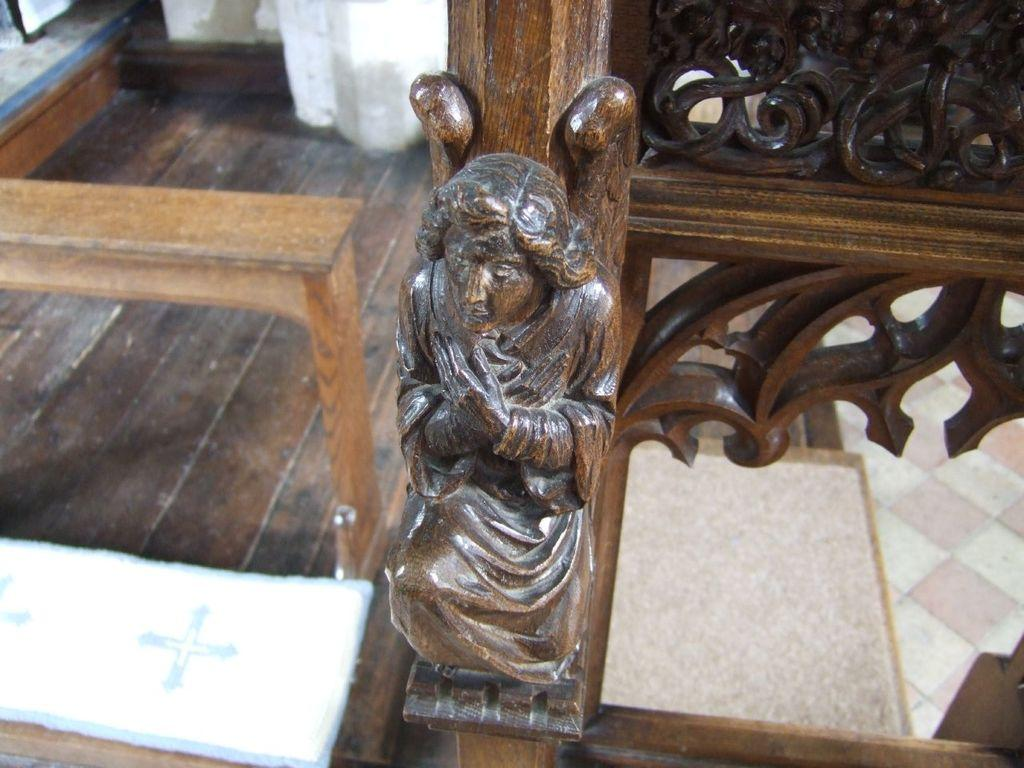What can be seen in the foreground of the picture? There are wooden sculptures and a bench in the foreground of the picture. What type of surface is present on the right side of the image? The right side of the image contains a floor. What is located at the top of the image? There is a well visible at the top of the image. What type of toy is being played with in the scene? There is no toy present in the image, and no one is playing in the scene. What is the chance of rain in the image? The image does not provide any information about the weather or the chance of rain. 